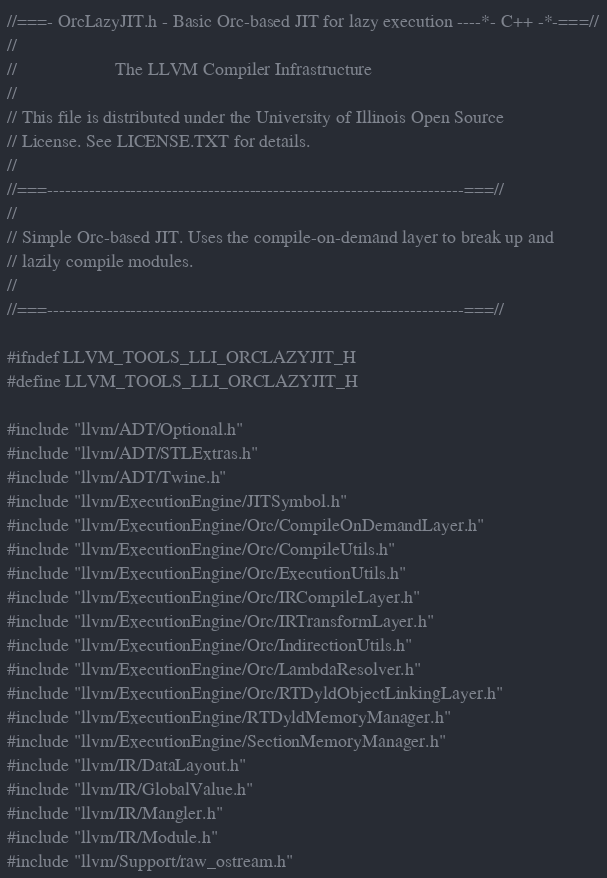<code> <loc_0><loc_0><loc_500><loc_500><_C_>//===- OrcLazyJIT.h - Basic Orc-based JIT for lazy execution ----*- C++ -*-===//
//
//                     The LLVM Compiler Infrastructure
//
// This file is distributed under the University of Illinois Open Source
// License. See LICENSE.TXT for details.
//
//===----------------------------------------------------------------------===//
//
// Simple Orc-based JIT. Uses the compile-on-demand layer to break up and
// lazily compile modules.
//
//===----------------------------------------------------------------------===//

#ifndef LLVM_TOOLS_LLI_ORCLAZYJIT_H
#define LLVM_TOOLS_LLI_ORCLAZYJIT_H

#include "llvm/ADT/Optional.h"
#include "llvm/ADT/STLExtras.h"
#include "llvm/ADT/Twine.h"
#include "llvm/ExecutionEngine/JITSymbol.h"
#include "llvm/ExecutionEngine/Orc/CompileOnDemandLayer.h"
#include "llvm/ExecutionEngine/Orc/CompileUtils.h"
#include "llvm/ExecutionEngine/Orc/ExecutionUtils.h"
#include "llvm/ExecutionEngine/Orc/IRCompileLayer.h"
#include "llvm/ExecutionEngine/Orc/IRTransformLayer.h"
#include "llvm/ExecutionEngine/Orc/IndirectionUtils.h"
#include "llvm/ExecutionEngine/Orc/LambdaResolver.h"
#include "llvm/ExecutionEngine/Orc/RTDyldObjectLinkingLayer.h"
#include "llvm/ExecutionEngine/RTDyldMemoryManager.h"
#include "llvm/ExecutionEngine/SectionMemoryManager.h"
#include "llvm/IR/DataLayout.h"
#include "llvm/IR/GlobalValue.h"
#include "llvm/IR/Mangler.h"
#include "llvm/IR/Module.h"
#include "llvm/Support/raw_ostream.h"</code> 